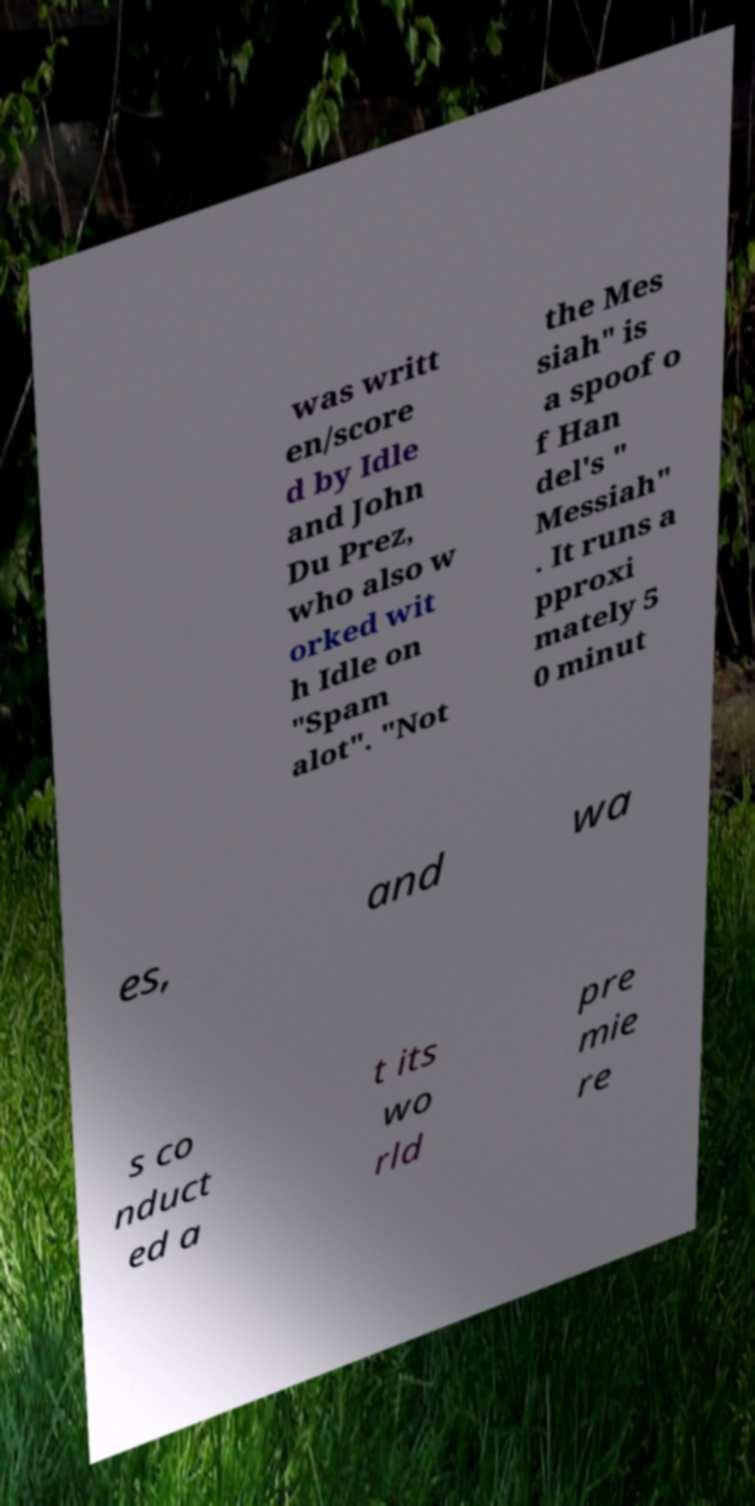There's text embedded in this image that I need extracted. Can you transcribe it verbatim? was writt en/score d by Idle and John Du Prez, who also w orked wit h Idle on "Spam alot". "Not the Mes siah" is a spoof o f Han del's " Messiah" . It runs a pproxi mately 5 0 minut es, and wa s co nduct ed a t its wo rld pre mie re 